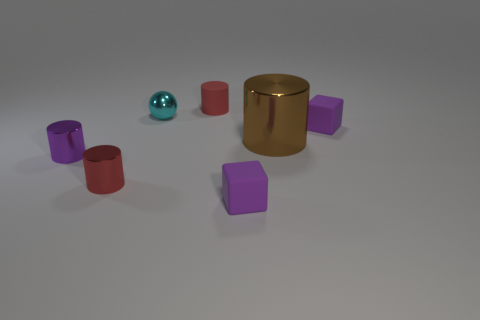Does the big thing in front of the cyan metallic ball have the same material as the tiny purple object that is behind the brown thing?
Your answer should be very brief. No. There is a thing that is the same color as the tiny matte cylinder; what shape is it?
Your response must be concise. Cylinder. Is the color of the big thing the same as the rubber cylinder?
Ensure brevity in your answer.  No. There is a red thing on the left side of the red rubber object; is it the same shape as the purple object that is left of the matte cylinder?
Your answer should be compact. Yes. What is the material of the other tiny red thing that is the same shape as the small red metal object?
Keep it short and to the point. Rubber. The thing that is both right of the small cyan object and in front of the brown shiny object is what color?
Provide a short and direct response. Purple. There is a small purple matte block that is in front of the purple block behind the brown metal thing; is there a small purple rubber cube to the right of it?
Ensure brevity in your answer.  Yes. How many objects are either cyan balls or small red metallic cylinders?
Your response must be concise. 2. Do the large brown object and the block on the left side of the brown object have the same material?
Give a very brief answer. No. Are there any other things that have the same color as the tiny sphere?
Offer a very short reply. No. 